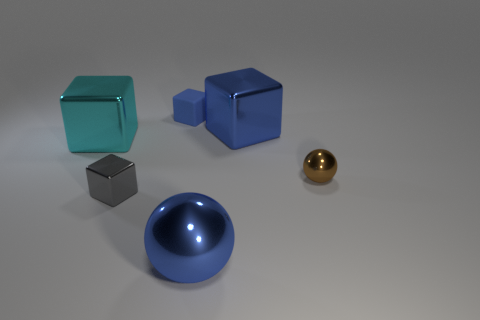Are there more gray shiny objects than brown rubber objects?
Make the answer very short. Yes. What color is the small metallic thing that is to the left of the brown thing?
Your answer should be very brief. Gray. Is the large cyan shiny thing the same shape as the tiny gray metal object?
Provide a short and direct response. Yes. What color is the thing that is both left of the big blue metal sphere and in front of the brown metallic ball?
Give a very brief answer. Gray. Do the object on the left side of the tiny gray metal block and the blue object that is in front of the cyan block have the same size?
Keep it short and to the point. Yes. How many objects are large cubes that are right of the small blue rubber thing or big yellow cubes?
Make the answer very short. 1. What is the material of the tiny brown object?
Provide a succinct answer. Metal. Does the brown ball have the same size as the rubber thing?
Keep it short and to the point. Yes. How many cubes are either metallic things or big purple objects?
Offer a very short reply. 3. What is the color of the small metallic thing behind the metallic cube that is in front of the tiny metal sphere?
Your answer should be very brief. Brown. 